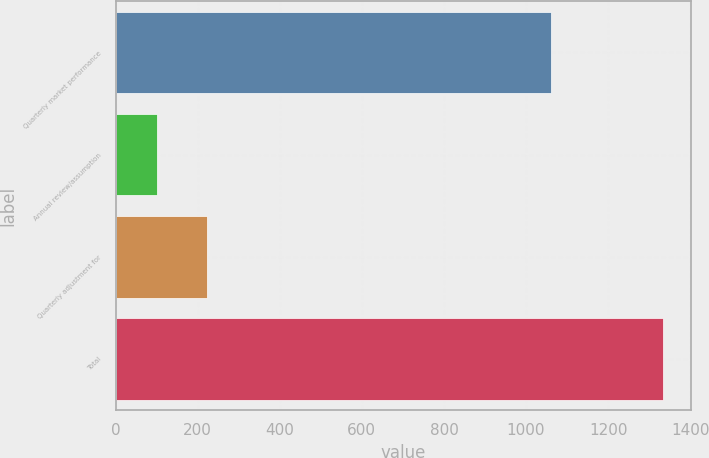Convert chart. <chart><loc_0><loc_0><loc_500><loc_500><bar_chart><fcel>Quarterly market performance<fcel>Annual review/assumption<fcel>Quarterly adjustment for<fcel>Total<nl><fcel>1060<fcel>100<fcel>223.4<fcel>1334<nl></chart> 